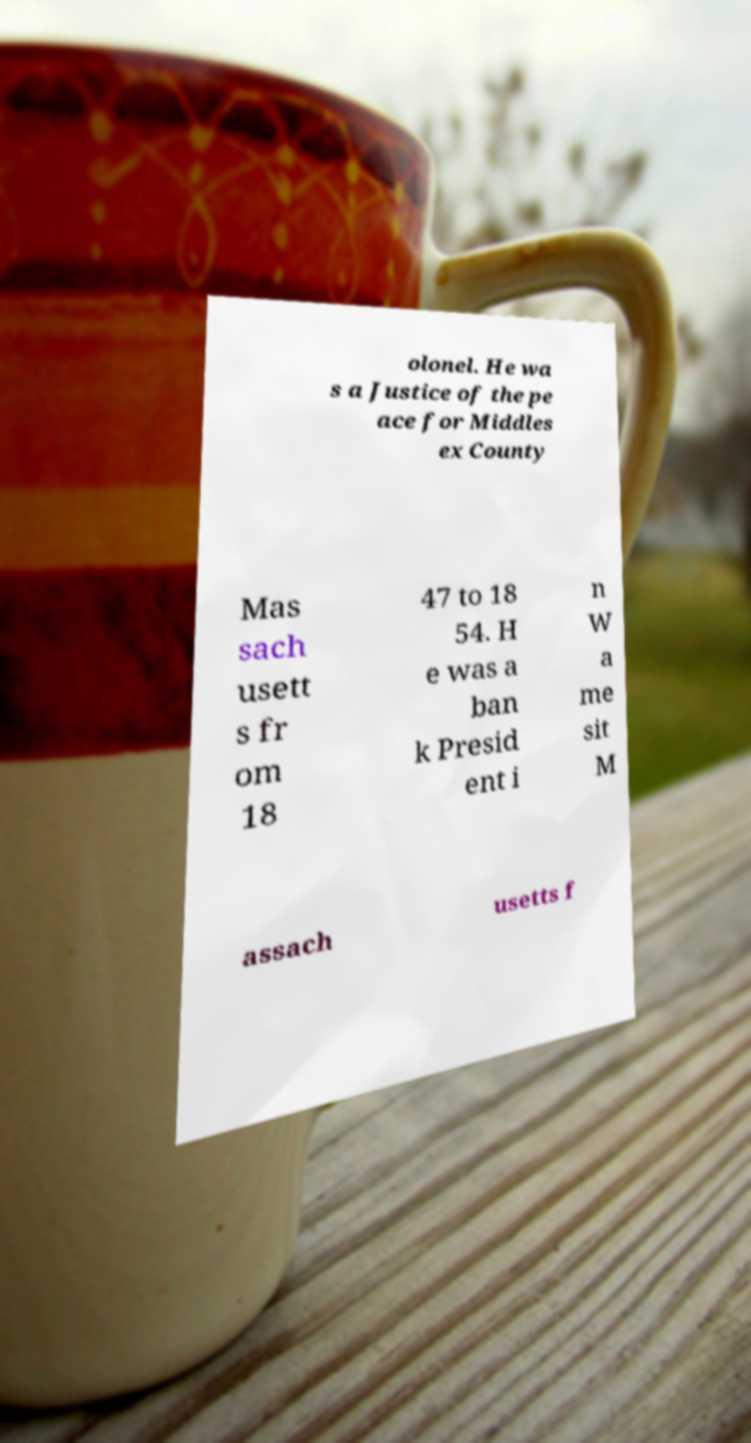I need the written content from this picture converted into text. Can you do that? olonel. He wa s a Justice of the pe ace for Middles ex County Mas sach usett s fr om 18 47 to 18 54. H e was a ban k Presid ent i n W a me sit M assach usetts f 